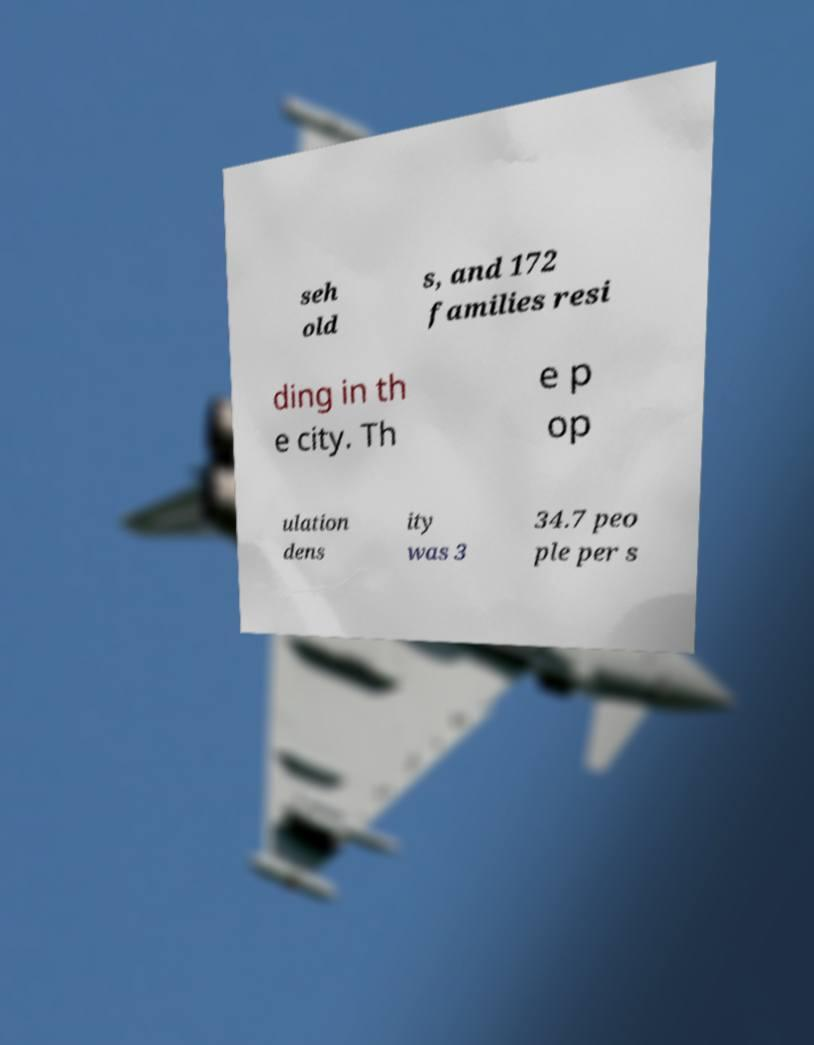There's text embedded in this image that I need extracted. Can you transcribe it verbatim? seh old s, and 172 families resi ding in th e city. Th e p op ulation dens ity was 3 34.7 peo ple per s 